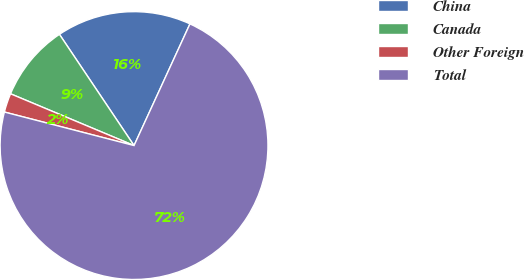Convert chart. <chart><loc_0><loc_0><loc_500><loc_500><pie_chart><fcel>China<fcel>Canada<fcel>Other Foreign<fcel>Total<nl><fcel>16.26%<fcel>9.28%<fcel>2.29%<fcel>72.17%<nl></chart> 